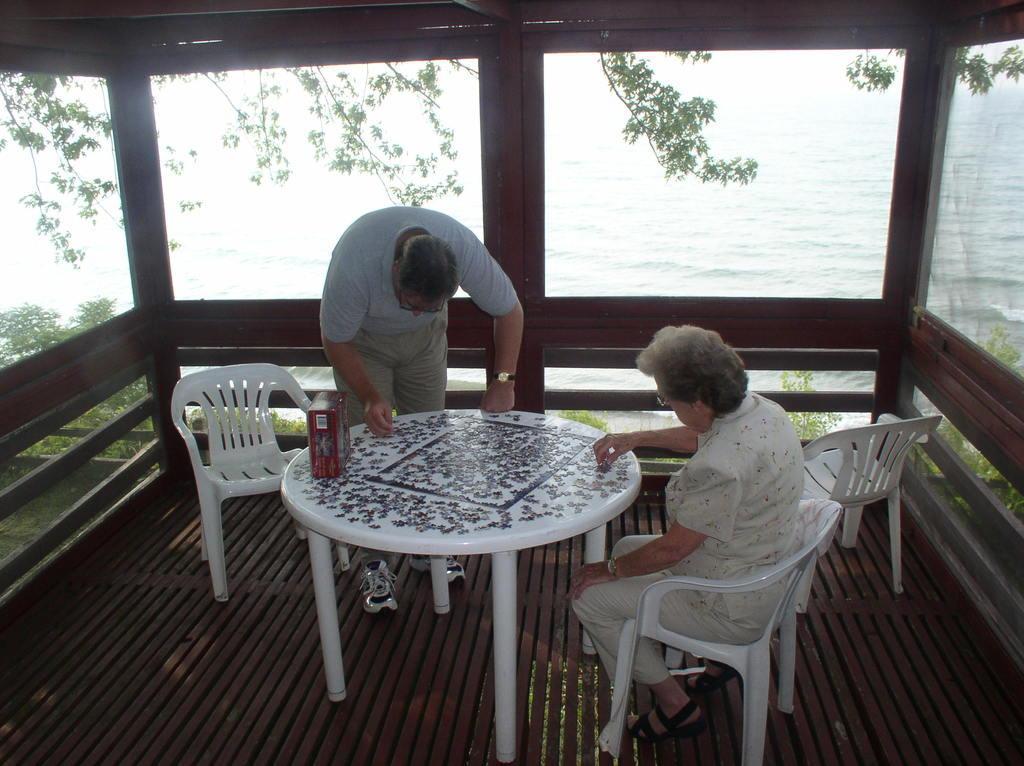Please provide a concise description of this image. It is a lawn of a house there is a white color table on which two people are sitting in the either side they are doing some work on the table, in the background there is a sea and trees. 